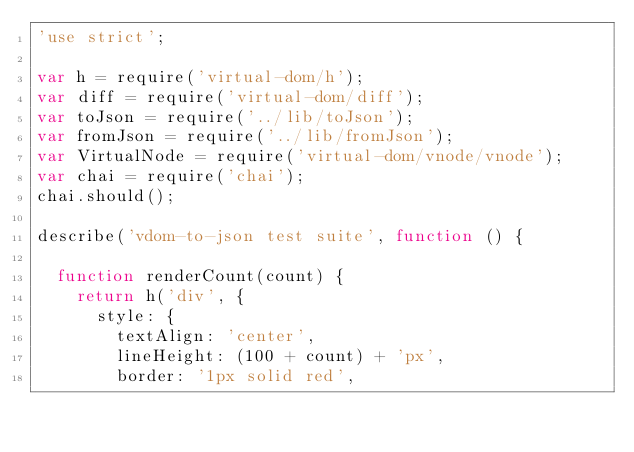Convert code to text. <code><loc_0><loc_0><loc_500><loc_500><_JavaScript_>'use strict';

var h = require('virtual-dom/h');
var diff = require('virtual-dom/diff');
var toJson = require('../lib/toJson');
var fromJson = require('../lib/fromJson');
var VirtualNode = require('virtual-dom/vnode/vnode');
var chai = require('chai');
chai.should();

describe('vdom-to-json test suite', function () {

  function renderCount(count) {
    return h('div', {
      style: {
        textAlign: 'center',
        lineHeight: (100 + count) + 'px',
        border: '1px solid red',</code> 